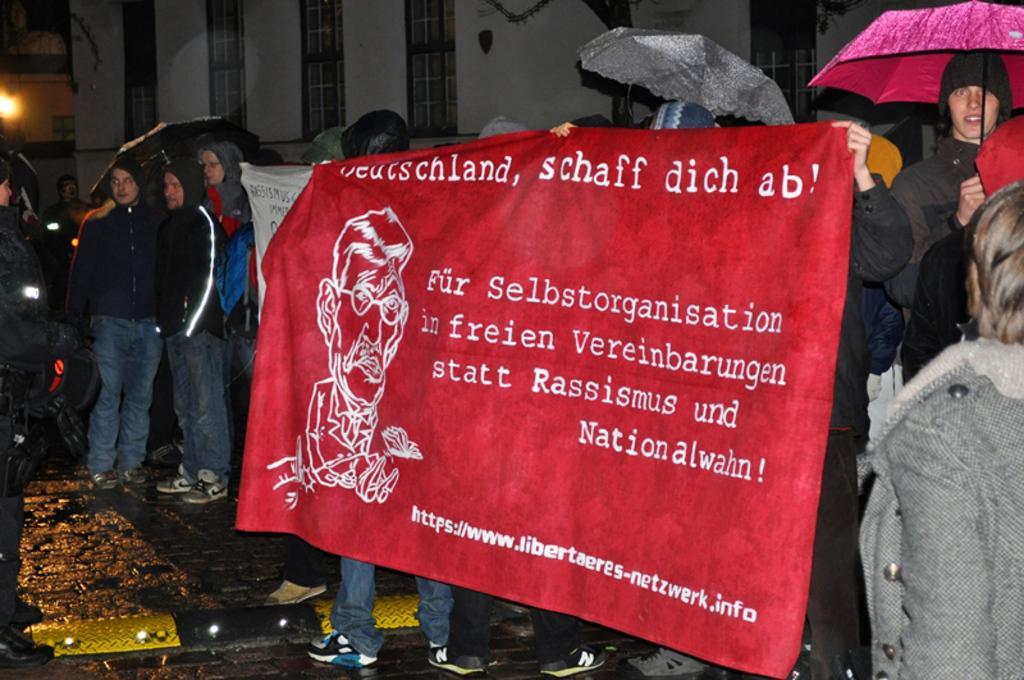How would you summarize this image in a sentence or two? In this image in the center there is a banner which is red in colour and there are some texts written on the banner and there are persons standing and holding banner. On the left side there are persons standing and on the right side there is a person standing and holding an umbrella which is pink in colour and there are umbrellas in the background. 